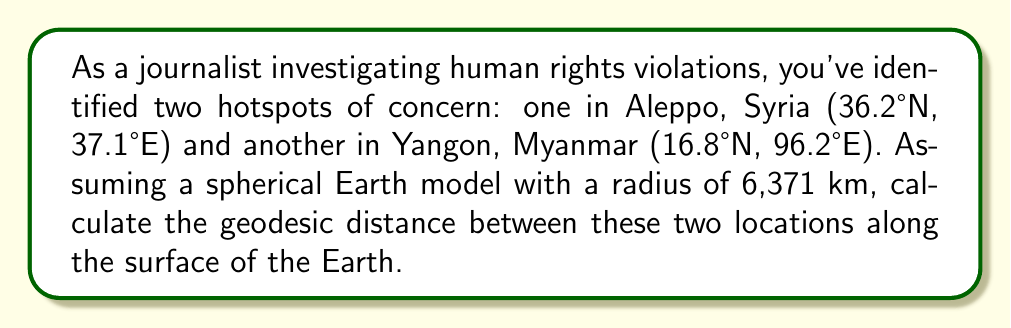Provide a solution to this math problem. To solve this problem, we'll use the Haversine formula, which calculates the great-circle distance between two points on a sphere given their latitudes and longitudes. This is an appropriate method for calculating geodesic distances on a spherical Earth model.

Let's define our variables:
$\phi_1, \lambda_1$: latitude and longitude of Aleppo (36.2°N, 37.1°E)
$\phi_2, \lambda_2$: latitude and longitude of Yangon (16.8°N, 96.2°E)
$r$: radius of the Earth (6,371 km)

Step 1: Convert degrees to radians
$$\phi_1 = 36.2° \times \frac{\pi}{180} = 0.6318 \text{ rad}$$
$$\lambda_1 = 37.1° \times \frac{\pi}{180} = 0.6475 \text{ rad}$$
$$\phi_2 = 16.8° \times \frac{\pi}{180} = 0.2932 \text{ rad}$$
$$\lambda_2 = 96.2° \times \frac{\pi}{180} = 1.6790 \text{ rad}$$

Step 2: Calculate the difference in longitude
$$\Delta\lambda = \lambda_2 - \lambda_1 = 1.6790 - 0.6475 = 1.0315 \text{ rad}$$

Step 3: Apply the Haversine formula
$$a = \sin^2\left(\frac{\phi_2 - \phi_1}{2}\right) + \cos(\phi_1)\cos(\phi_2)\sin^2\left(\frac{\Delta\lambda}{2}\right)$$

$$a = \sin^2\left(\frac{0.2932 - 0.6318}{2}\right) + \cos(0.6318)\cos(0.2932)\sin^2\left(\frac{1.0315}{2}\right)$$

$$a = 0.0289 + (0.8071 \times 0.9573 \times 0.2208) = 0.2073$$

Step 4: Calculate the central angle
$$c = 2 \times \arctan2(\sqrt{a}, \sqrt{1-a})$$
$$c = 2 \times \arctan2(\sqrt{0.2073}, \sqrt{1-0.2073}) = 0.9498 \text{ rad}$$

Step 5: Calculate the geodesic distance
$$d = r \times c = 6371 \times 0.9498 = 6051.4 \text{ km}$$

Thus, the geodesic distance between Aleppo and Yangon on our spherical Earth model is approximately 6051.4 km.
Answer: The geodesic distance between Aleppo, Syria and Yangon, Myanmar on a spherical Earth model with radius 6,371 km is approximately 6051.4 km. 